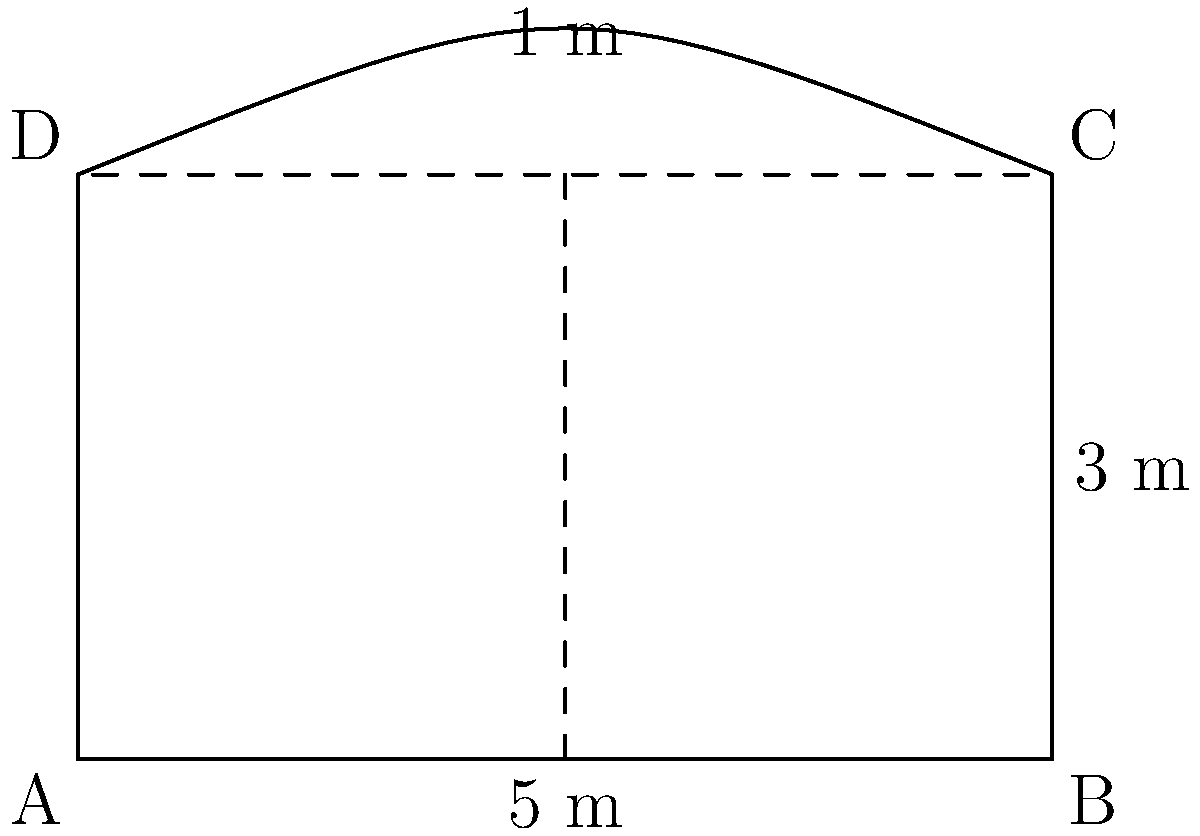You've designed a new card table with an innovative curved edge for your casino. The table's shape is shown in the diagram, where the top edge is curved outward. The straight edges of the table measure 5 meters in length and 3 meters in width. The curved section adds an extra 1 meter to the middle of the top edge when compared to a straight edge. Calculate the perimeter of this uniquely shaped card table. To find the perimeter of this irregularly shaped card table, we need to:

1. Calculate the length of the straight edges:
   - Bottom edge: 5 m
   - Left edge: 3 m
   - Right edge: 3 m
   Total straight edge length: $5 + 3 + 3 = 11$ m

2. Estimate the length of the curved edge:
   - The curve extends 1 m beyond the straight line at its peak
   - We can approximate the curve as an arc of a circle
   - The chord length of this arc is 5 m (the straight-line distance)
   - Using the formula for arc length: $L = r\theta$, where $r$ is the radius and $\theta$ is the central angle in radians
   - We can estimate $r \approx \frac{5^2 + 1^2}{4(1)} = 3.25$ m
   - The central angle $\theta = 2 \arcsin(\frac{5}{2r}) \approx 1.651$ radians
   - Arc length $L = 3.25 \times 1.651 \approx 5.37$ m

3. Sum up all sides:
   Total perimeter $= 11 + 5.37 = 16.37$ m
Answer: Approximately 16.37 meters 